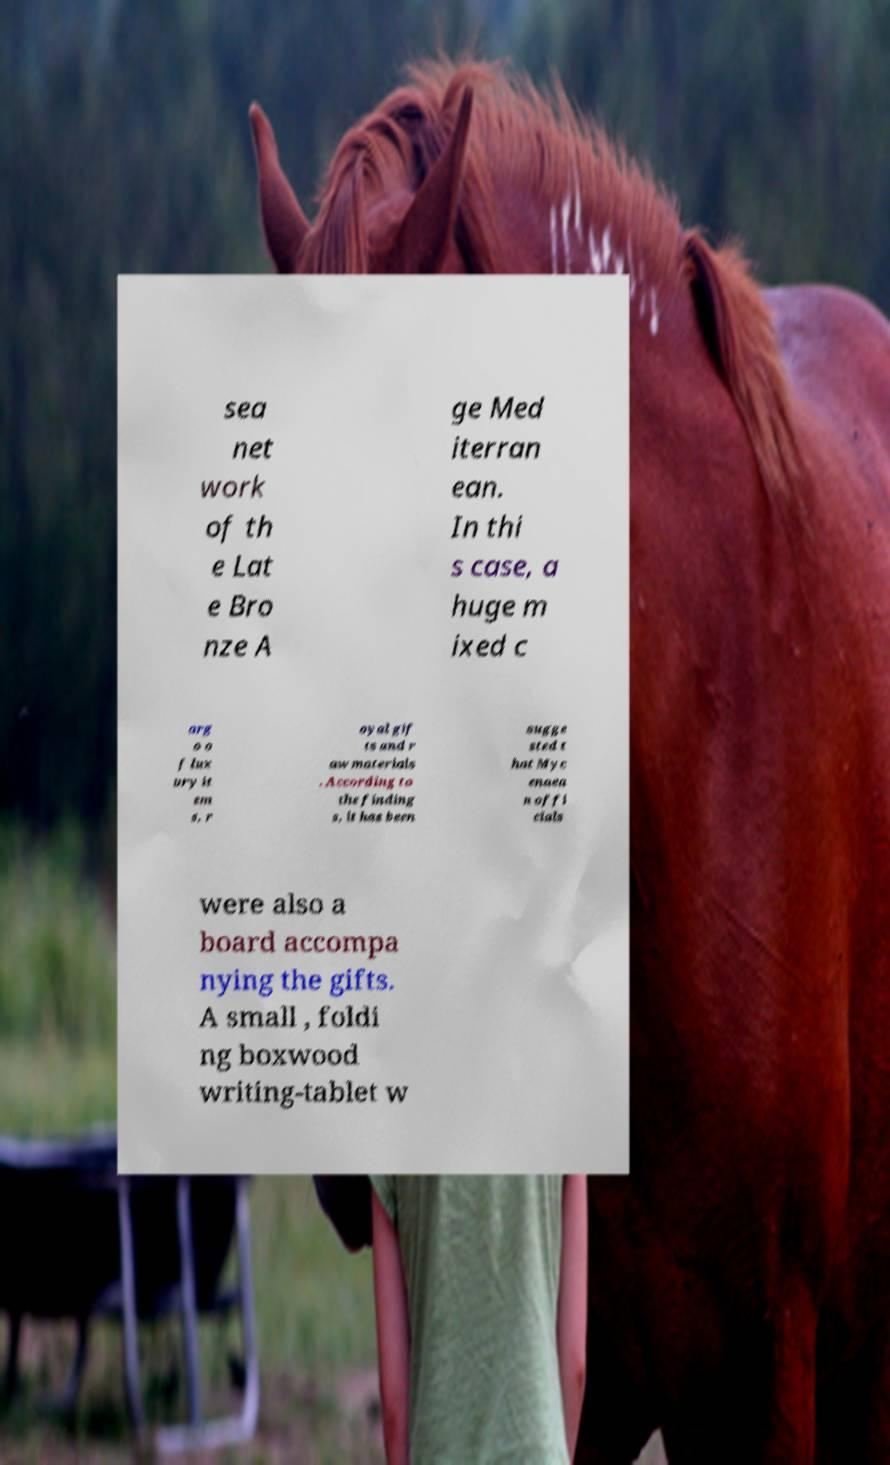Please identify and transcribe the text found in this image. sea net work of th e Lat e Bro nze A ge Med iterran ean. In thi s case, a huge m ixed c arg o o f lux ury it em s, r oyal gif ts and r aw materials . According to the finding s, it has been sugge sted t hat Myc enaea n offi cials were also a board accompa nying the gifts. A small , foldi ng boxwood writing-tablet w 